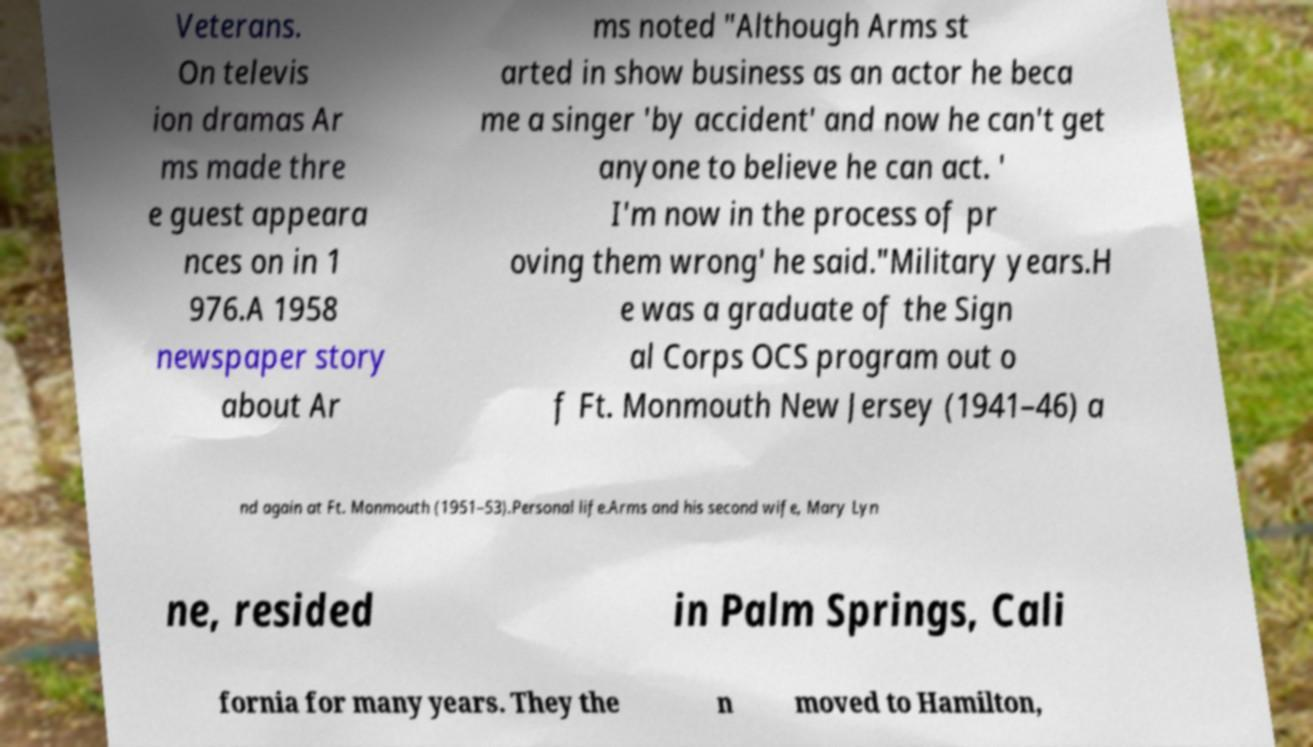Please identify and transcribe the text found in this image. Veterans. On televis ion dramas Ar ms made thre e guest appeara nces on in 1 976.A 1958 newspaper story about Ar ms noted "Although Arms st arted in show business as an actor he beca me a singer 'by accident' and now he can't get anyone to believe he can act. ' I'm now in the process of pr oving them wrong' he said."Military years.H e was a graduate of the Sign al Corps OCS program out o f Ft. Monmouth New Jersey (1941–46) a nd again at Ft. Monmouth (1951–53).Personal life.Arms and his second wife, Mary Lyn ne, resided in Palm Springs, Cali fornia for many years. They the n moved to Hamilton, 